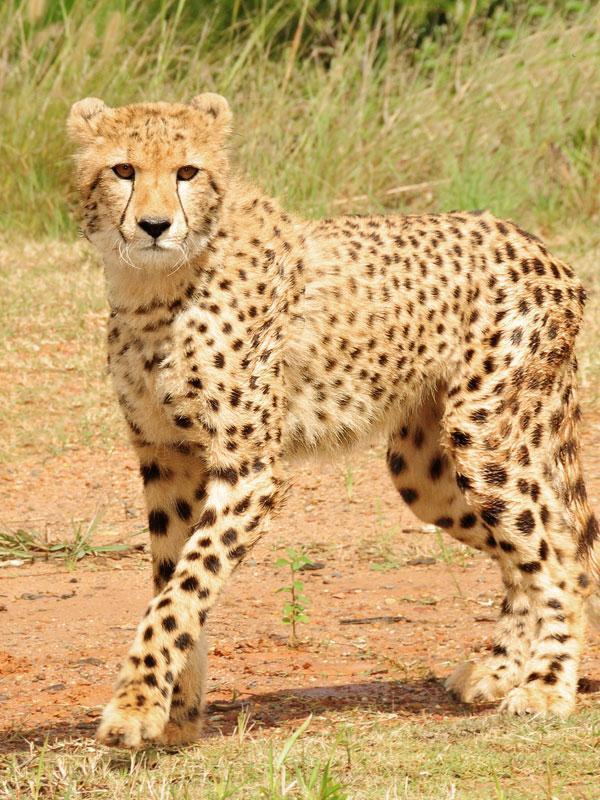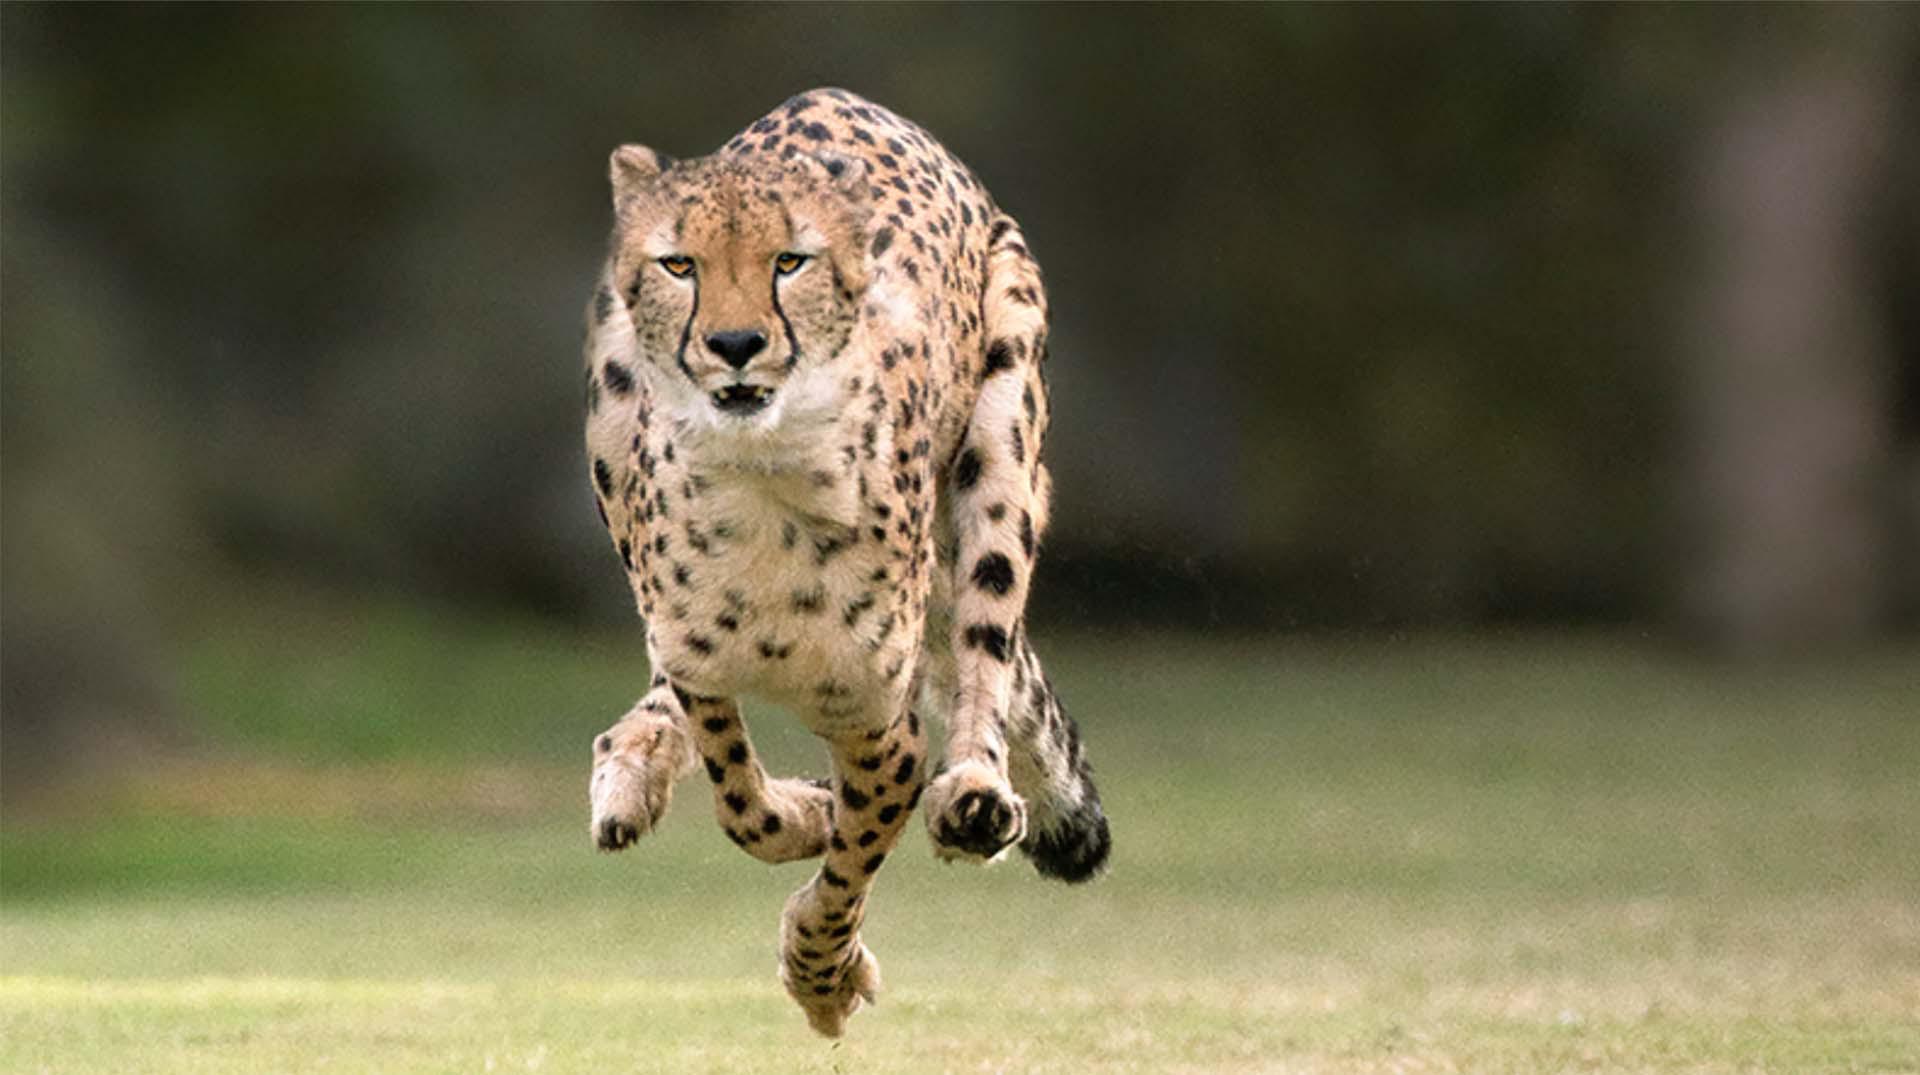The first image is the image on the left, the second image is the image on the right. Evaluate the accuracy of this statement regarding the images: "Exactly three cheetahs are shown, with two in one image sedentary, and the third in the other image running with its front paws off the ground.". Is it true? Answer yes or no. No. The first image is the image on the left, the second image is the image on the right. Analyze the images presented: Is the assertion "Several animals are in a grassy are in the image on the left." valid? Answer yes or no. No. 